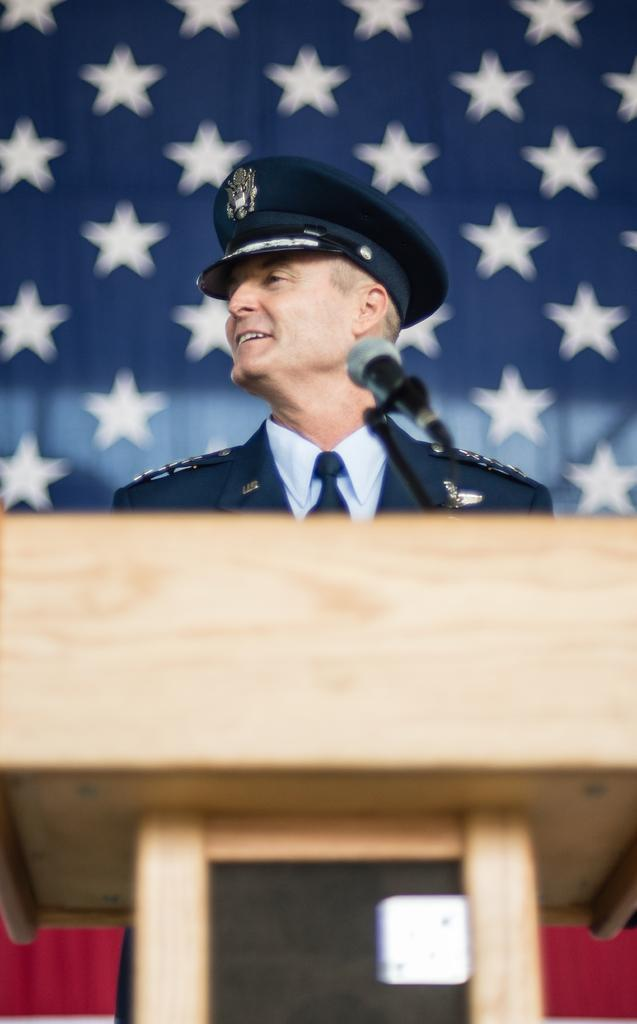What can be seen in the background of the image? There is a colorful cloth in the background of the image. Who is present in the image? There is a man in the image. What is the man wearing on his head? The man is wearing a cap. Where is the man standing in the image? The man is standing near a podium. What is the man's facial expression in the image? The man is smiling. What object is present for the man to speak into? There is a microphone in the image. What is the man leaning on or holding in the image? There is a stand in the image. What type of crook is the man holding in the image? There is no crook present in the image; the man is standing near a podium and there is a microphone and a stand in the image. What list is the man referring to while standing near the podium? There is no list mentioned or visible in the image; the man is simply standing near a podium with a microphone and a stand. 